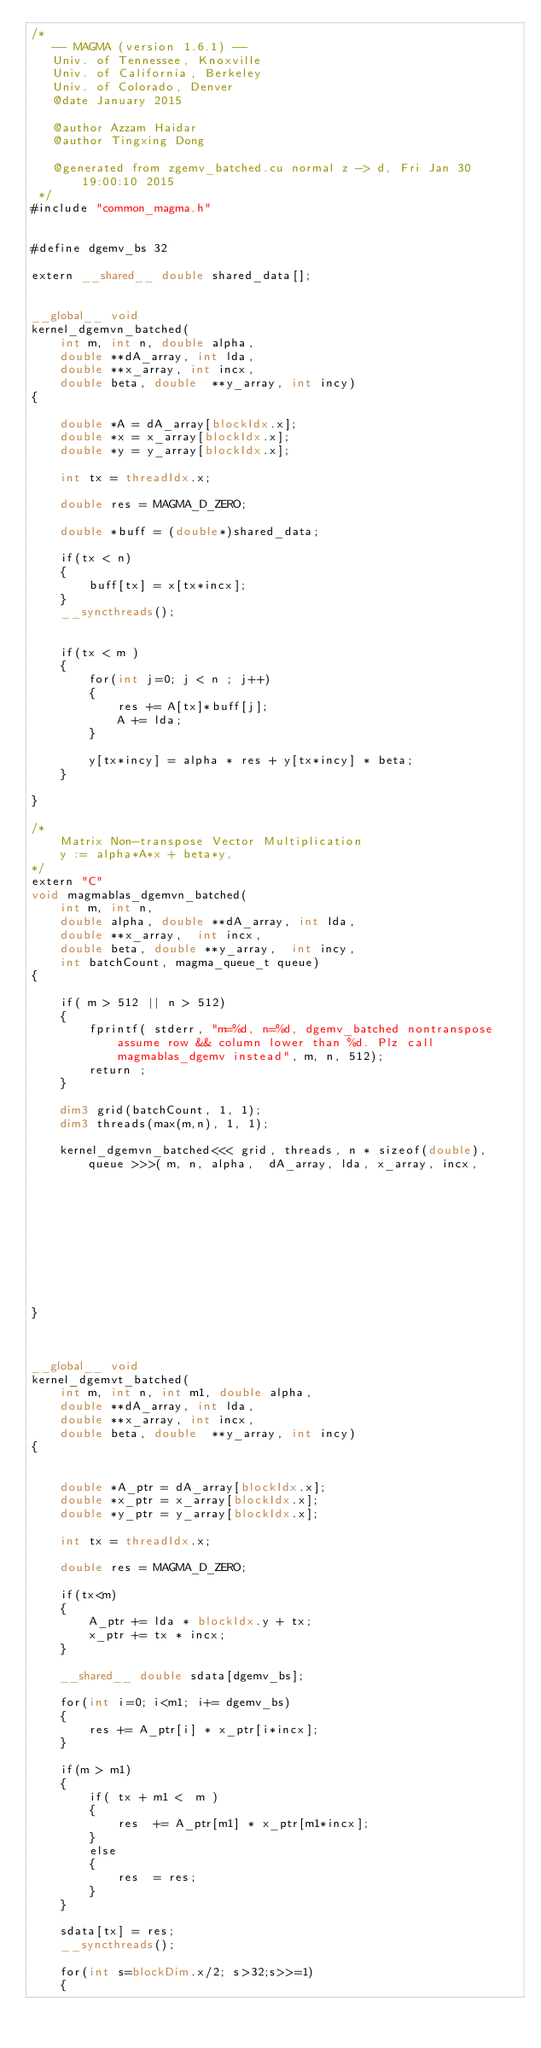Convert code to text. <code><loc_0><loc_0><loc_500><loc_500><_Cuda_>/*
   -- MAGMA (version 1.6.1) --
   Univ. of Tennessee, Knoxville
   Univ. of California, Berkeley
   Univ. of Colorado, Denver
   @date January 2015

   @author Azzam Haidar
   @author Tingxing Dong

   @generated from zgemv_batched.cu normal z -> d, Fri Jan 30 19:00:10 2015
 */
#include "common_magma.h"


#define dgemv_bs 32

extern __shared__ double shared_data[];


__global__ void
kernel_dgemvn_batched(
    int m, int n, double alpha,
    double **dA_array, int lda,
    double **x_array, int incx,
    double beta, double  **y_array, int incy)
{

    double *A = dA_array[blockIdx.x];
    double *x = x_array[blockIdx.x];
    double *y = y_array[blockIdx.x];

    int tx = threadIdx.x;

    double res = MAGMA_D_ZERO;

    double *buff = (double*)shared_data;

    if(tx < n)
    {
        buff[tx] = x[tx*incx];
    }
    __syncthreads();
   
    
    if(tx < m )
    {
        for(int j=0; j < n ; j++)
        {
            res += A[tx]*buff[j];
            A += lda;
        }
  
        y[tx*incy] = alpha * res + y[tx*incy] * beta;
    }

}

/*
    Matrix Non-transpose Vector Multiplication
    y := alpha*A*x + beta*y,
*/
extern "C"
void magmablas_dgemvn_batched(
    int m, int n, 
    double alpha, double **dA_array, int lda, 
    double **x_array,  int incx,
    double beta, double **y_array,  int incy, 
    int batchCount, magma_queue_t queue)
{

    if( m > 512 || n > 512)
    {
        fprintf( stderr, "m=%d, n=%d, dgemv_batched nontranspose assume row && column lower than %d. Plz call magmablas_dgemv instead", m, n, 512);
        return ;
    }

    dim3 grid(batchCount, 1, 1);
    dim3 threads(max(m,n), 1, 1);
   
    kernel_dgemvn_batched<<< grid, threads, n * sizeof(double), queue >>>( m, n, alpha,  dA_array, lda, x_array, incx,  
                                                                         beta, y_array, incy);
}



__global__ void
kernel_dgemvt_batched(
    int m, int n, int m1, double alpha,
    double **dA_array, int lda,
    double **x_array, int incx,
    double beta, double  **y_array, int incy)
{
  

    double *A_ptr = dA_array[blockIdx.x];
    double *x_ptr = x_array[blockIdx.x];
    double *y_ptr = y_array[blockIdx.x];

    int tx = threadIdx.x;
    
    double res = MAGMA_D_ZERO;

    if(tx<m)
    {  
        A_ptr += lda * blockIdx.y + tx;
        x_ptr += tx * incx;
    }
        
    __shared__ double sdata[dgemv_bs];

    for(int i=0; i<m1; i+= dgemv_bs)
    {
        res += A_ptr[i] * x_ptr[i*incx];
    }

    if(m > m1)
    {
        if( tx + m1 <  m )
        {
            res  += A_ptr[m1] * x_ptr[m1*incx];
        }
        else
        {
            res  = res;
        }
    }

    sdata[tx] = res;
    __syncthreads();

    for(int s=blockDim.x/2; s>32;s>>=1)
    {</code> 